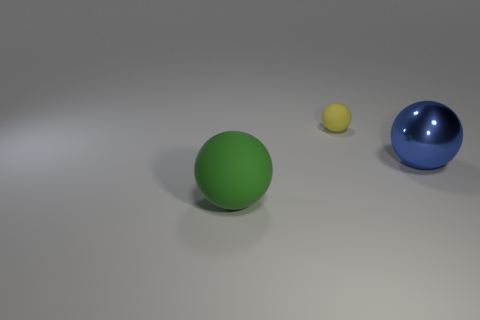Add 1 tiny spheres. How many objects exist? 4 Subtract all green spheres. Subtract all tiny yellow things. How many objects are left? 1 Add 2 tiny yellow objects. How many tiny yellow objects are left? 3 Add 1 large blue matte cubes. How many large blue matte cubes exist? 1 Subtract 0 gray spheres. How many objects are left? 3 